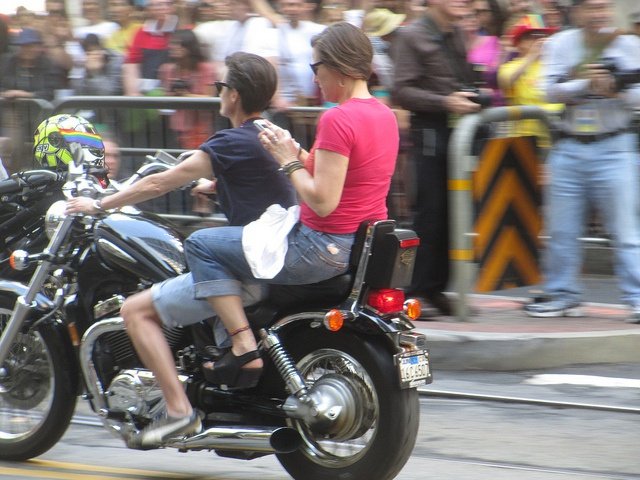Describe the objects in this image and their specific colors. I can see motorcycle in white, black, gray, and darkgray tones, people in white, gray, lightpink, and salmon tones, people in white, gray, and darkgray tones, people in white, gray, black, and darkgray tones, and people in white, black, and gray tones in this image. 